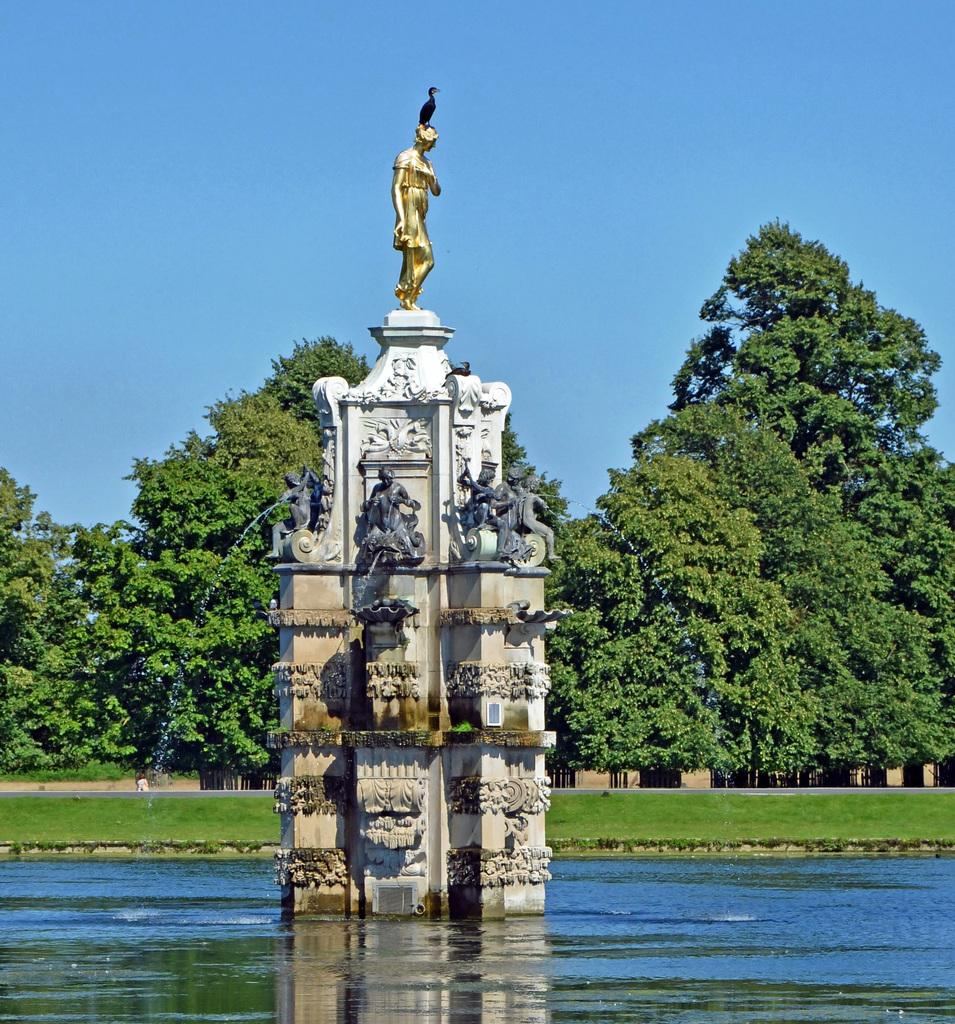What type of objects can be seen in the image? There are statues in the image. What material are the statues made of? The statues are made of stone. What natural elements are present in the image? There is water and grass in the image. What can be seen in the background of the image? There are trees and the sky visible in the background of the image. Where is the calculator located in the image? There is no calculator present in the image. What type of dolls can be seen playing near the water in the image? There are no dolls present in the image; it features statues, stone, water, grass, trees, and the sky. 